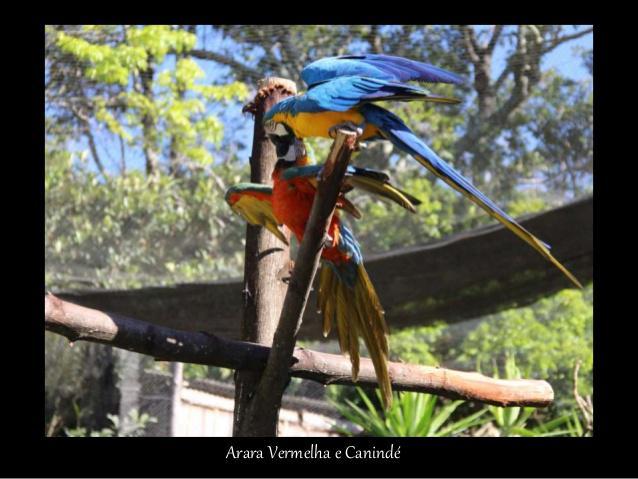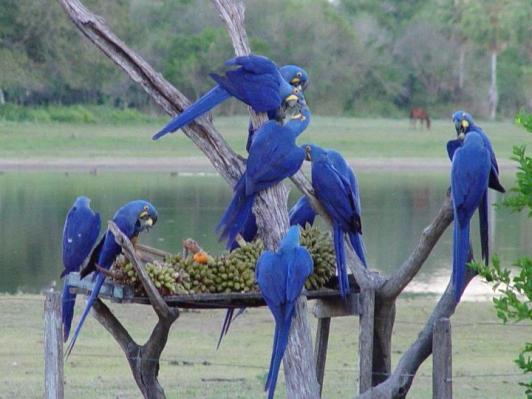The first image is the image on the left, the second image is the image on the right. Assess this claim about the two images: "The right image features at least six blue parrots.". Correct or not? Answer yes or no. Yes. 